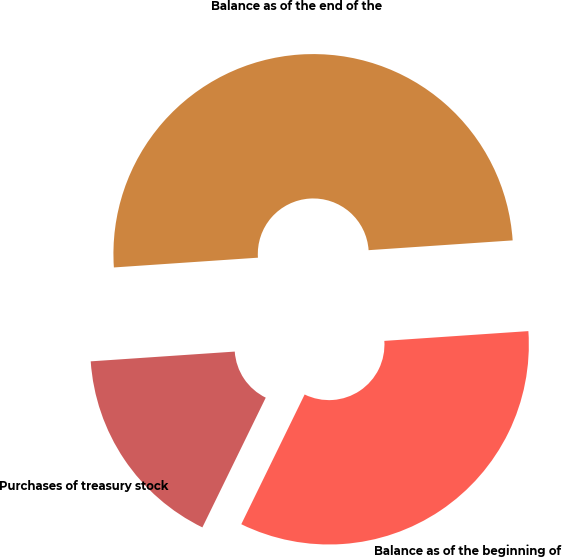Convert chart to OTSL. <chart><loc_0><loc_0><loc_500><loc_500><pie_chart><fcel>Balance as of the beginning of<fcel>Purchases of treasury stock<fcel>Balance as of the end of the<nl><fcel>33.31%<fcel>16.69%<fcel>50.0%<nl></chart> 